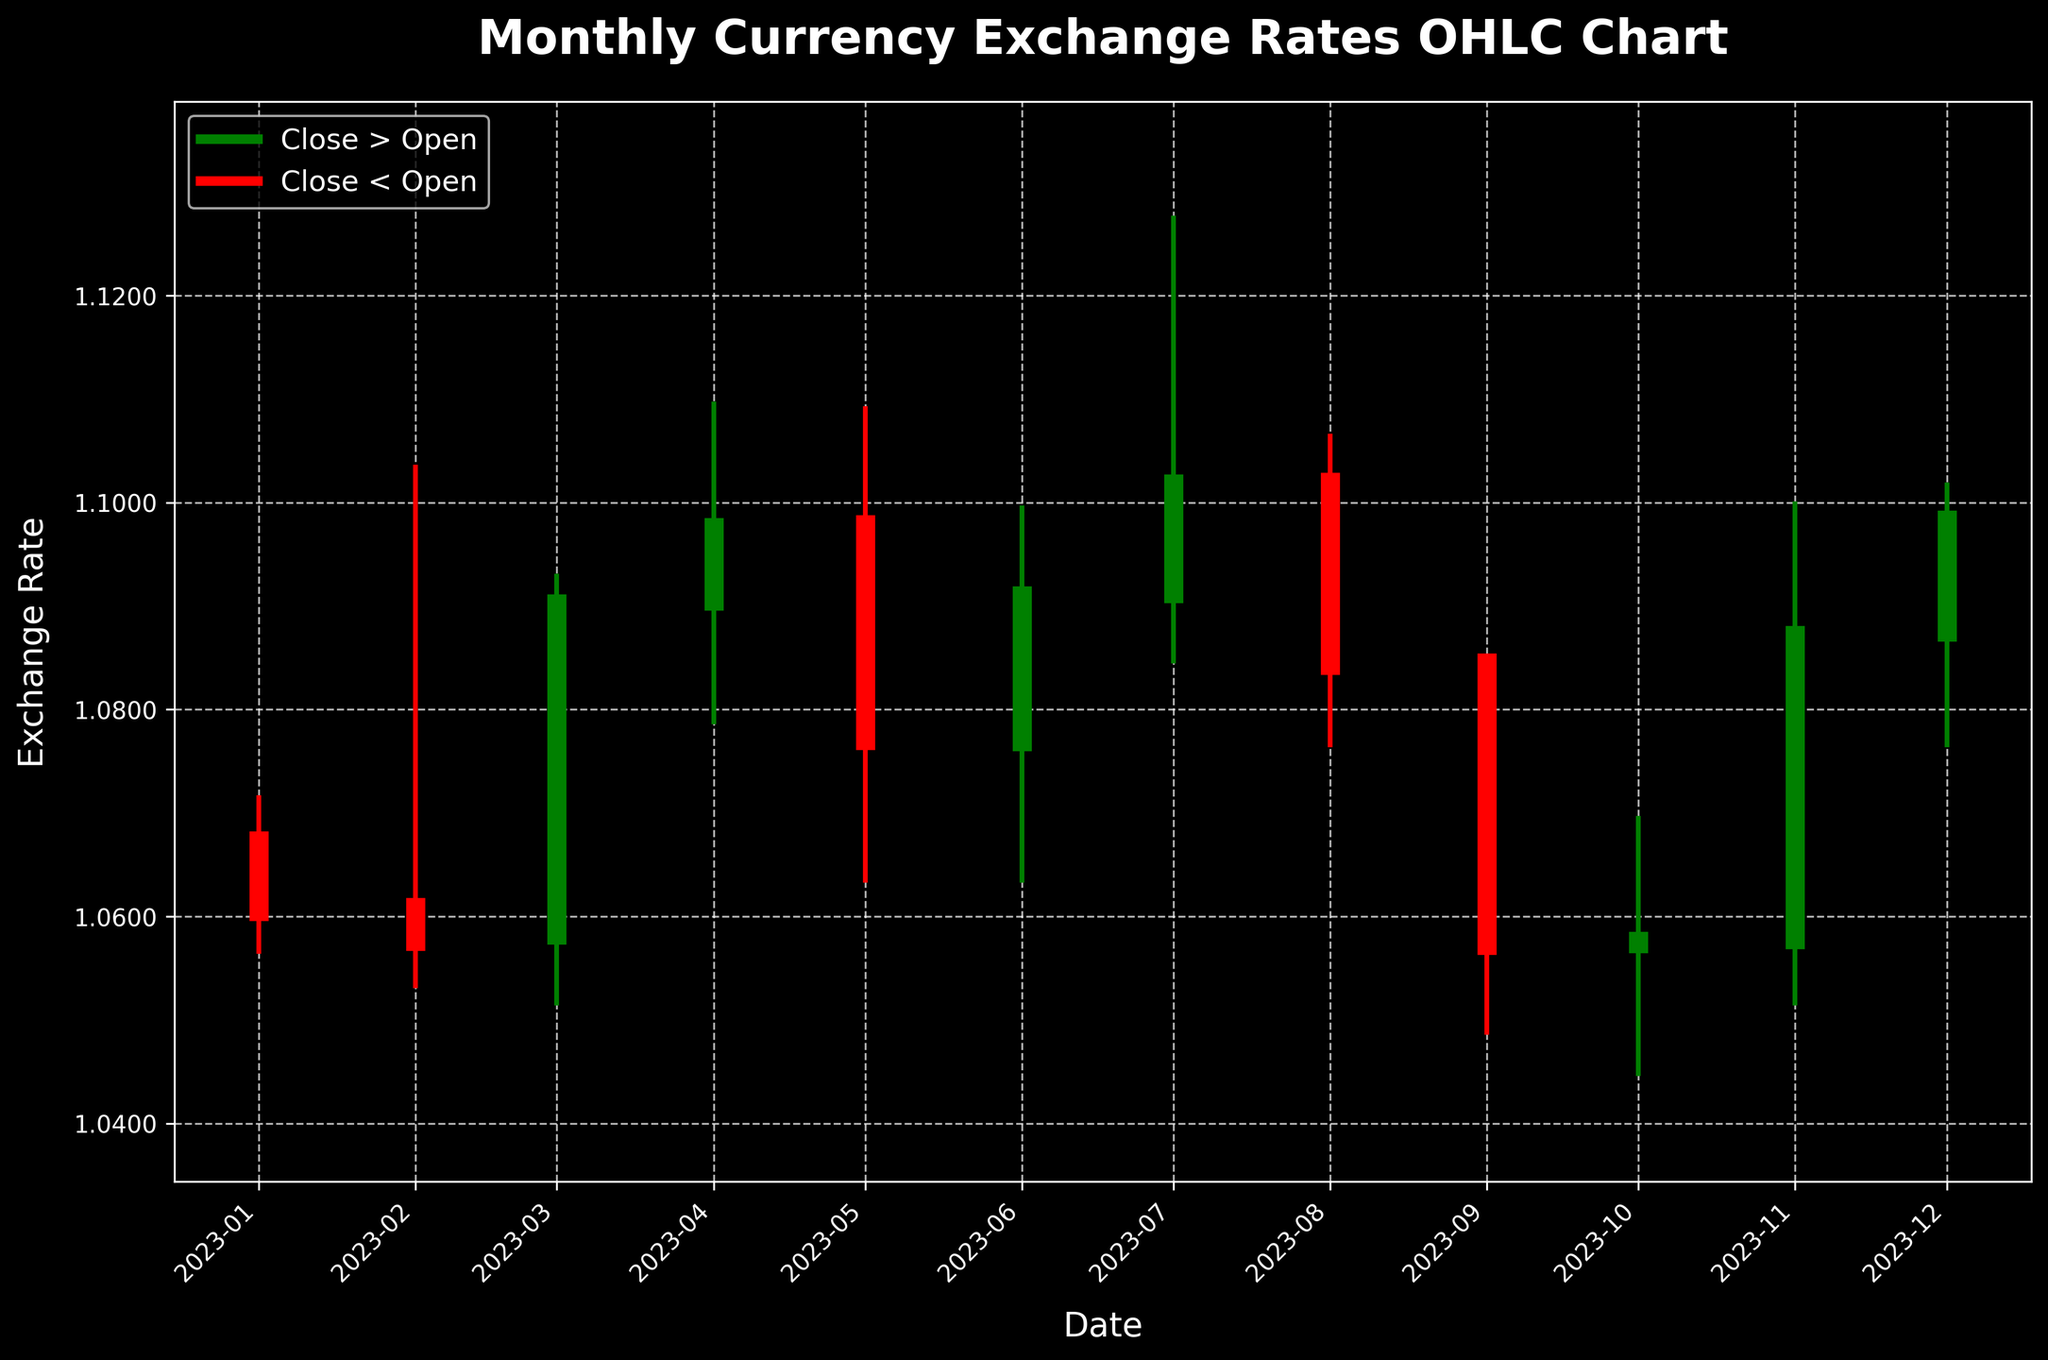How many months of data are presented in the chart? There are 12 candlesticks on the chart which represent 12 months of data.
Answer: 12 What is the highest exchange rate observed in the chart? The highest point on the chart corresponds to the highest "High" value, which is 1.1275 observed in July 2023.
Answer: 1.1275 Which month had the largest difference between the high and low prices? By visually comparing the length of the vertical lines representing the high and low prices for each month, April 2023 stands out with the highest vertical difference from high (1.1095) to low (1.0788).
Answer: April 2023 What is the general trend of the exchange rate from January to December 2023? By looking at the trend of the closing prices (thicker parts of the candlestick) from January to December, we observe a slight general increase, though it is not strictly ascending every month. The overall trend is upward.
Answer: Upward Trend Which month had the smallest range between the opening and closing prices? The range between the opening and closing prices is shown by the thick bar of the candlesticks. September 2023 has the smallest range as both the top and bottom of the thick bar are very close (Open 1.0845, Close 1.0572).
Answer: September 2023 Did more months close higher or lower than they opened? Green bars indicate months where the closing price was higher than the opening, and red bars indicate the opposite. There are 7 green bars and 5 red bars. Thus, more months closed higher than they opened.
Answer: Higher What is the exchange rate at the close of December 2023, and how did it compare to the prior month? The closing rate for December 2023 is 1.0983. The prior month's closing rate is 1.0872, showing an increase in December.
Answer: 1.0983, Increased Which month saw the biggest drop in the exchange rate from the opening to the closing price? The month with the largest drop is indicated by the largest red bar. September 2023 has the largest drop from opening at 1.0845 to closing at 1.0572.
Answer: September 2023 What's the average closing rate from January to December 2023? To find the average closing rate, sum all closing rates and divide by the number of months. (1.0605 + 1.0576 + 1.0902 + 1.0976 + 1.0770 + 1.0910 + 1.1018 + 1.0843 + 1.0572 + 1.0576 + 1.0872 + 1.0983) / 12 = 1.0793
Answer: 1.0793 